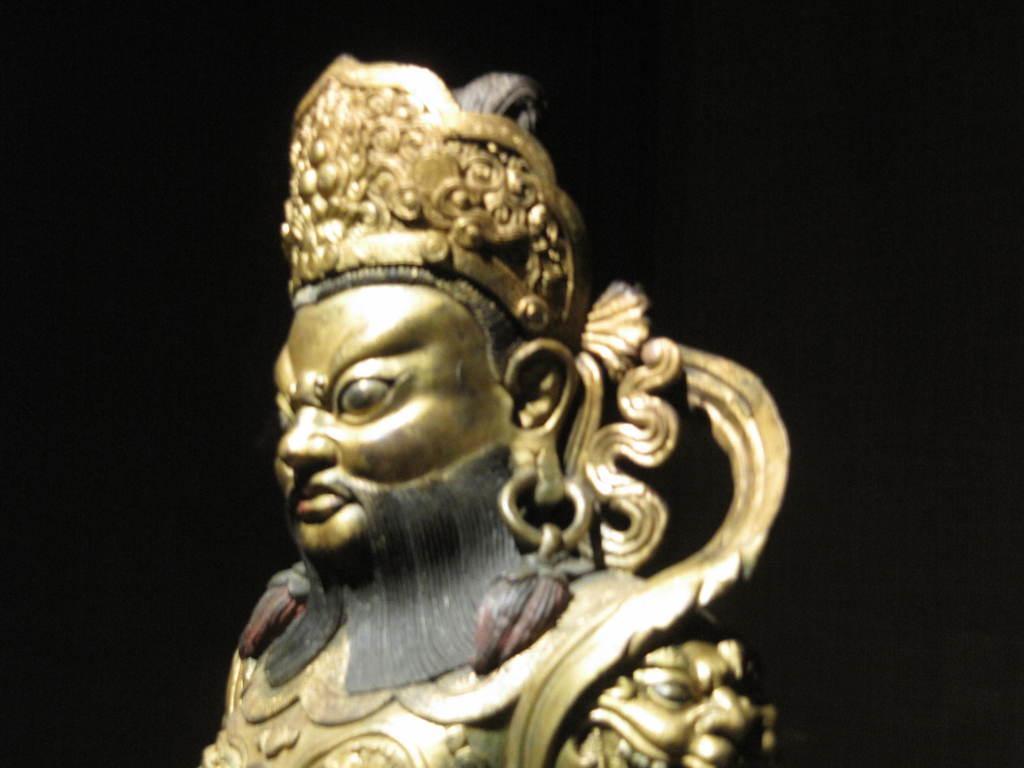Can you describe this image briefly? In this image there is a metal statue and the background is black. 